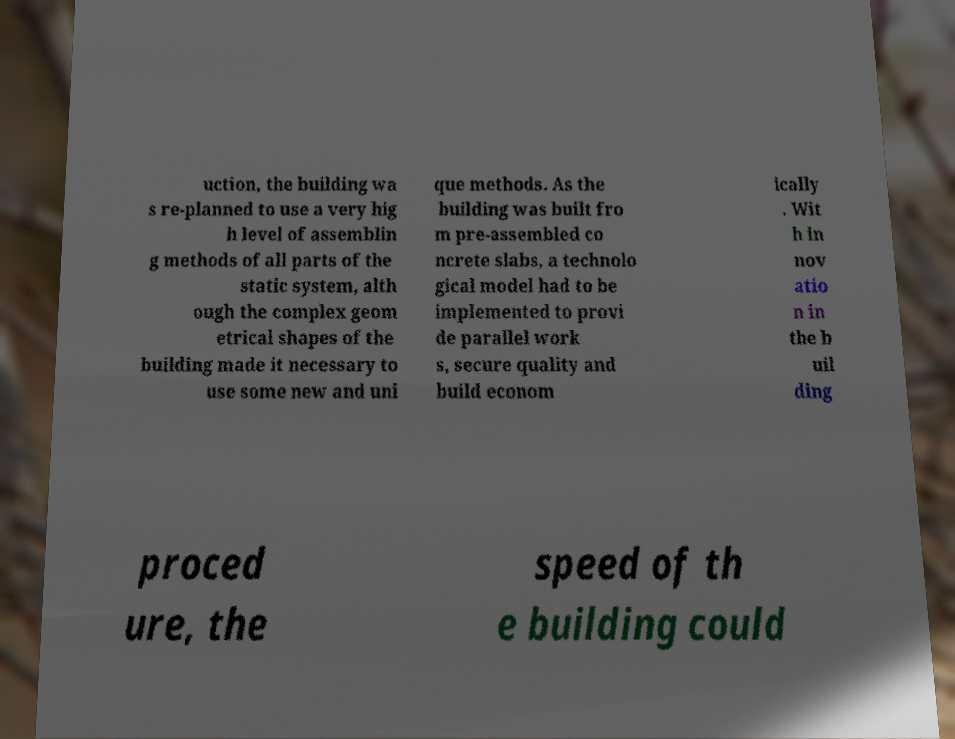Can you accurately transcribe the text from the provided image for me? uction, the building wa s re-planned to use a very hig h level of assemblin g methods of all parts of the static system, alth ough the complex geom etrical shapes of the building made it necessary to use some new and uni que methods. As the building was built fro m pre-assembled co ncrete slabs, a technolo gical model had to be implemented to provi de parallel work s, secure quality and build econom ically . Wit h in nov atio n in the b uil ding proced ure, the speed of th e building could 